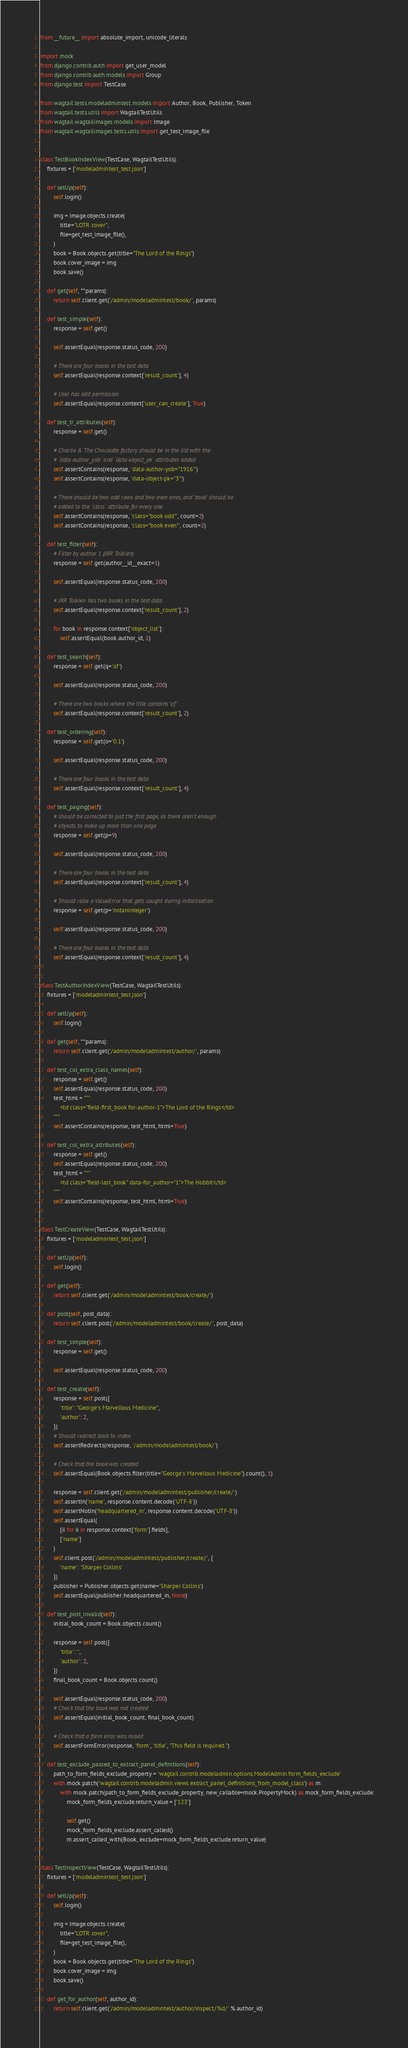Convert code to text. <code><loc_0><loc_0><loc_500><loc_500><_Python_>from __future__ import absolute_import, unicode_literals

import mock
from django.contrib.auth import get_user_model
from django.contrib.auth.models import Group
from django.test import TestCase

from wagtail.tests.modeladmintest.models import Author, Book, Publisher, Token
from wagtail.tests.utils import WagtailTestUtils
from wagtail.wagtailimages.models import Image
from wagtail.wagtailimages.tests.utils import get_test_image_file


class TestBookIndexView(TestCase, WagtailTestUtils):
    fixtures = ['modeladmintest_test.json']

    def setUp(self):
        self.login()

        img = Image.objects.create(
            title="LOTR cover",
            file=get_test_image_file(),
        )
        book = Book.objects.get(title="The Lord of the Rings")
        book.cover_image = img
        book.save()

    def get(self, **params):
        return self.client.get('/admin/modeladmintest/book/', params)

    def test_simple(self):
        response = self.get()

        self.assertEqual(response.status_code, 200)

        # There are four books in the test data
        self.assertEqual(response.context['result_count'], 4)

        # User has add permission
        self.assertEqual(response.context['user_can_create'], True)

    def test_tr_attributes(self):
        response = self.get()

        # Charlie & The Chocolate factory should be in the list with the
        # `data-author_yob` and `data-object_pk` attributes added
        self.assertContains(response, 'data-author-yob="1916"')
        self.assertContains(response, 'data-object-pk="3"')

        # There should be two odd rows and two even ones, and 'book' should be
        # added to the `class` attribute for every one.
        self.assertContains(response, 'class="book odd"', count=2)
        self.assertContains(response, 'class="book even"', count=2)

    def test_filter(self):
        # Filter by author 1 (JRR Tolkien)
        response = self.get(author__id__exact=1)

        self.assertEqual(response.status_code, 200)

        # JRR Tolkien has two books in the test data
        self.assertEqual(response.context['result_count'], 2)

        for book in response.context['object_list']:
            self.assertEqual(book.author_id, 1)

    def test_search(self):
        response = self.get(q='of')

        self.assertEqual(response.status_code, 200)

        # There are two books where the title contains 'of'
        self.assertEqual(response.context['result_count'], 2)

    def test_ordering(self):
        response = self.get(o='0.1')

        self.assertEqual(response.status_code, 200)

        # There are four books in the test data
        self.assertEqual(response.context['result_count'], 4)

    def test_paging(self):
        # should be corrected to just the first page, as there aren't enough
        # objects to make up more than one page
        response = self.get(p=9)

        self.assertEqual(response.status_code, 200)

        # There are four books in the test data
        self.assertEqual(response.context['result_count'], 4)

        # Should raise a ValueError that gets caught during initialisation
        response = self.get(p='notaninteger')

        self.assertEqual(response.status_code, 200)

        # There are four books in the test data
        self.assertEqual(response.context['result_count'], 4)


class TestAuthorIndexView(TestCase, WagtailTestUtils):
    fixtures = ['modeladmintest_test.json']

    def setUp(self):
        self.login()

    def get(self, **params):
        return self.client.get('/admin/modeladmintest/author/', params)

    def test_col_extra_class_names(self):
        response = self.get()
        self.assertEqual(response.status_code, 200)
        test_html = """
            <td class="field-first_book for-author-1">The Lord of the Rings</td>
        """
        self.assertContains(response, test_html, html=True)

    def test_col_extra_attributes(self):
        response = self.get()
        self.assertEqual(response.status_code, 200)
        test_html = """
            <td class="field-last_book" data-for_author="1">The Hobbit</td>
        """
        self.assertContains(response, test_html, html=True)


class TestCreateView(TestCase, WagtailTestUtils):
    fixtures = ['modeladmintest_test.json']

    def setUp(self):
        self.login()

    def get(self):
        return self.client.get('/admin/modeladmintest/book/create/')

    def post(self, post_data):
        return self.client.post('/admin/modeladmintest/book/create/', post_data)

    def test_simple(self):
        response = self.get()

        self.assertEqual(response.status_code, 200)

    def test_create(self):
        response = self.post({
            'title': "George's Marvellous Medicine",
            'author': 2,
        })
        # Should redirect back to index
        self.assertRedirects(response, '/admin/modeladmintest/book/')

        # Check that the book was created
        self.assertEqual(Book.objects.filter(title="George's Marvellous Medicine").count(), 1)

        response = self.client.get('/admin/modeladmintest/publisher/create/')
        self.assertIn('name', response.content.decode('UTF-8'))
        self.assertNotIn('headquartered_in', response.content.decode('UTF-8'))
        self.assertEqual(
            [ii for ii in response.context['form'].fields],
            ['name']
        )
        self.client.post('/admin/modeladmintest/publisher/create/', {
            'name': 'Sharper Collins'
        })
        publisher = Publisher.objects.get(name='Sharper Collins')
        self.assertEqual(publisher.headquartered_in, None)

    def test_post_invalid(self):
        initial_book_count = Book.objects.count()

        response = self.post({
            'title': '',
            'author': 2,
        })
        final_book_count = Book.objects.count()

        self.assertEqual(response.status_code, 200)
        # Check that the book was not created
        self.assertEqual(initial_book_count, final_book_count)

        # Check that a form error was raised
        self.assertFormError(response, 'form', 'title', "This field is required.")

    def test_exclude_passed_to_extract_panel_definitions(self):
        path_to_form_fields_exclude_property = 'wagtail.contrib.modeladmin.options.ModelAdmin.form_fields_exclude'
        with mock.patch('wagtail.contrib.modeladmin.views.extract_panel_definitions_from_model_class') as m:
            with mock.patch(path_to_form_fields_exclude_property, new_callable=mock.PropertyMock) as mock_form_fields_exclude:
                mock_form_fields_exclude.return_value = ['123']

                self.get()
                mock_form_fields_exclude.assert_called()
                m.assert_called_with(Book, exclude=mock_form_fields_exclude.return_value)


class TestInspectView(TestCase, WagtailTestUtils):
    fixtures = ['modeladmintest_test.json']

    def setUp(self):
        self.login()

        img = Image.objects.create(
            title="LOTR cover",
            file=get_test_image_file(),
        )
        book = Book.objects.get(title="The Lord of the Rings")
        book.cover_image = img
        book.save()

    def get_for_author(self, author_id):
        return self.client.get('/admin/modeladmintest/author/inspect/%d/' % author_id)
</code> 